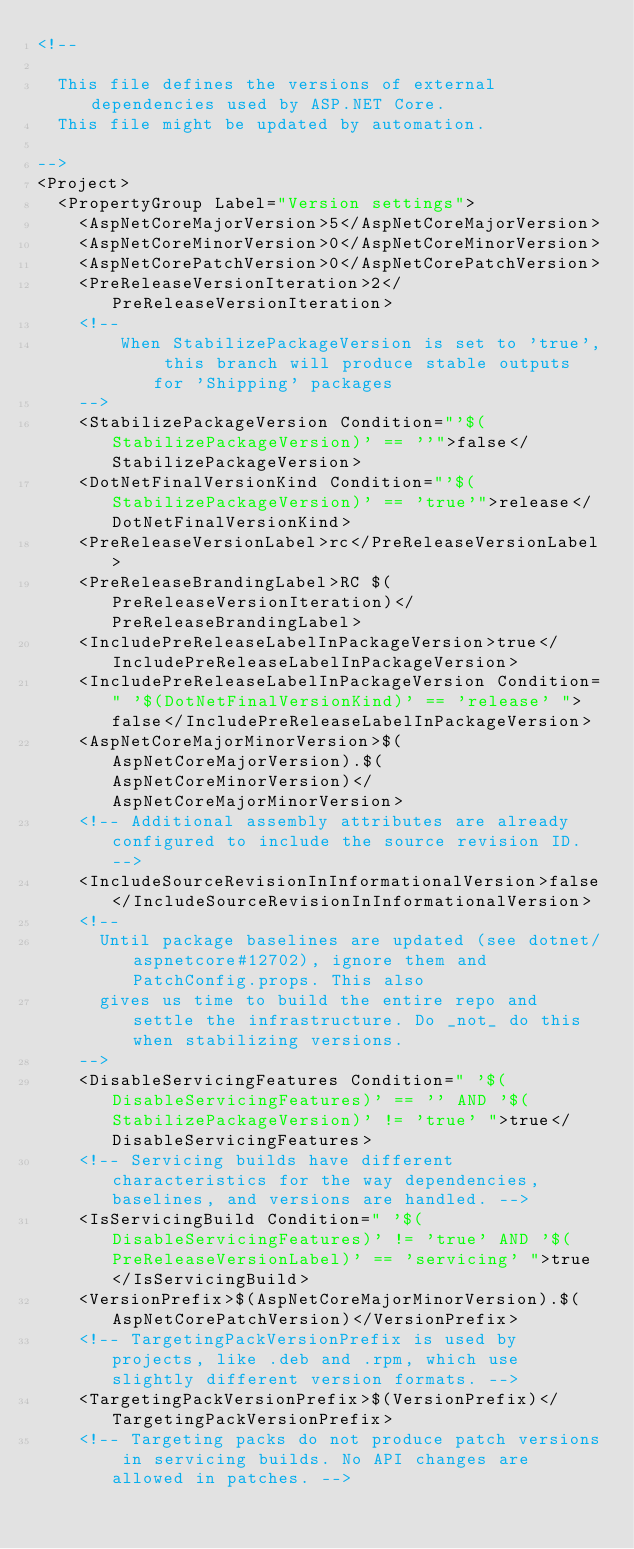Convert code to text. <code><loc_0><loc_0><loc_500><loc_500><_XML_><!--

  This file defines the versions of external dependencies used by ASP.NET Core.
  This file might be updated by automation.

-->
<Project>
  <PropertyGroup Label="Version settings">
    <AspNetCoreMajorVersion>5</AspNetCoreMajorVersion>
    <AspNetCoreMinorVersion>0</AspNetCoreMinorVersion>
    <AspNetCorePatchVersion>0</AspNetCorePatchVersion>
    <PreReleaseVersionIteration>2</PreReleaseVersionIteration>
    <!--
        When StabilizePackageVersion is set to 'true', this branch will produce stable outputs for 'Shipping' packages
    -->
    <StabilizePackageVersion Condition="'$(StabilizePackageVersion)' == ''">false</StabilizePackageVersion>
    <DotNetFinalVersionKind Condition="'$(StabilizePackageVersion)' == 'true'">release</DotNetFinalVersionKind>
    <PreReleaseVersionLabel>rc</PreReleaseVersionLabel>
    <PreReleaseBrandingLabel>RC $(PreReleaseVersionIteration)</PreReleaseBrandingLabel>
    <IncludePreReleaseLabelInPackageVersion>true</IncludePreReleaseLabelInPackageVersion>
    <IncludePreReleaseLabelInPackageVersion Condition=" '$(DotNetFinalVersionKind)' == 'release' ">false</IncludePreReleaseLabelInPackageVersion>
    <AspNetCoreMajorMinorVersion>$(AspNetCoreMajorVersion).$(AspNetCoreMinorVersion)</AspNetCoreMajorMinorVersion>
    <!-- Additional assembly attributes are already configured to include the source revision ID. -->
    <IncludeSourceRevisionInInformationalVersion>false</IncludeSourceRevisionInInformationalVersion>
    <!--
      Until package baselines are updated (see dotnet/aspnetcore#12702), ignore them and PatchConfig.props. This also
      gives us time to build the entire repo and settle the infrastructure. Do _not_ do this when stabilizing versions.
    -->
    <DisableServicingFeatures Condition=" '$(DisableServicingFeatures)' == '' AND '$(StabilizePackageVersion)' != 'true' ">true</DisableServicingFeatures>
    <!-- Servicing builds have different characteristics for the way dependencies, baselines, and versions are handled. -->
    <IsServicingBuild Condition=" '$(DisableServicingFeatures)' != 'true' AND '$(PreReleaseVersionLabel)' == 'servicing' ">true</IsServicingBuild>
    <VersionPrefix>$(AspNetCoreMajorMinorVersion).$(AspNetCorePatchVersion)</VersionPrefix>
    <!-- TargetingPackVersionPrefix is used by projects, like .deb and .rpm, which use slightly different version formats. -->
    <TargetingPackVersionPrefix>$(VersionPrefix)</TargetingPackVersionPrefix>
    <!-- Targeting packs do not produce patch versions in servicing builds. No API changes are allowed in patches. --></code> 